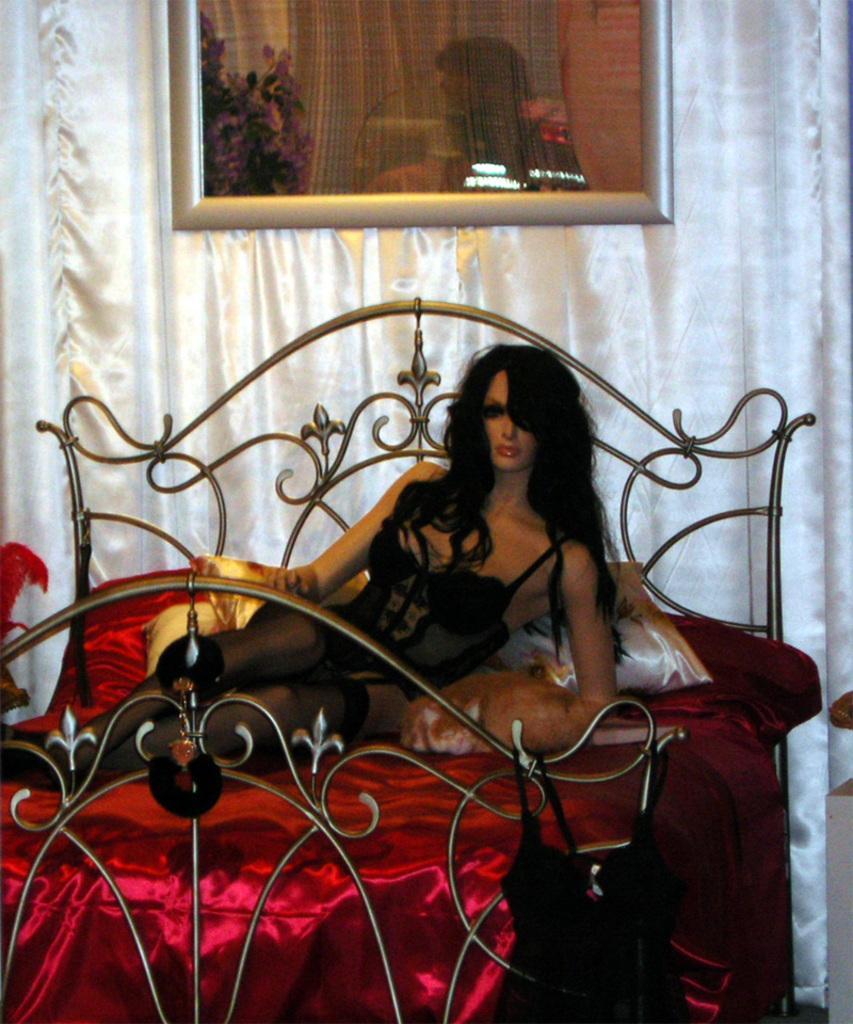Can you describe this image briefly? There is a statue of a lady on the bed. On the bed there is red bed cover, pillows. On the wall there is a frame. There are white curtains in the background. 